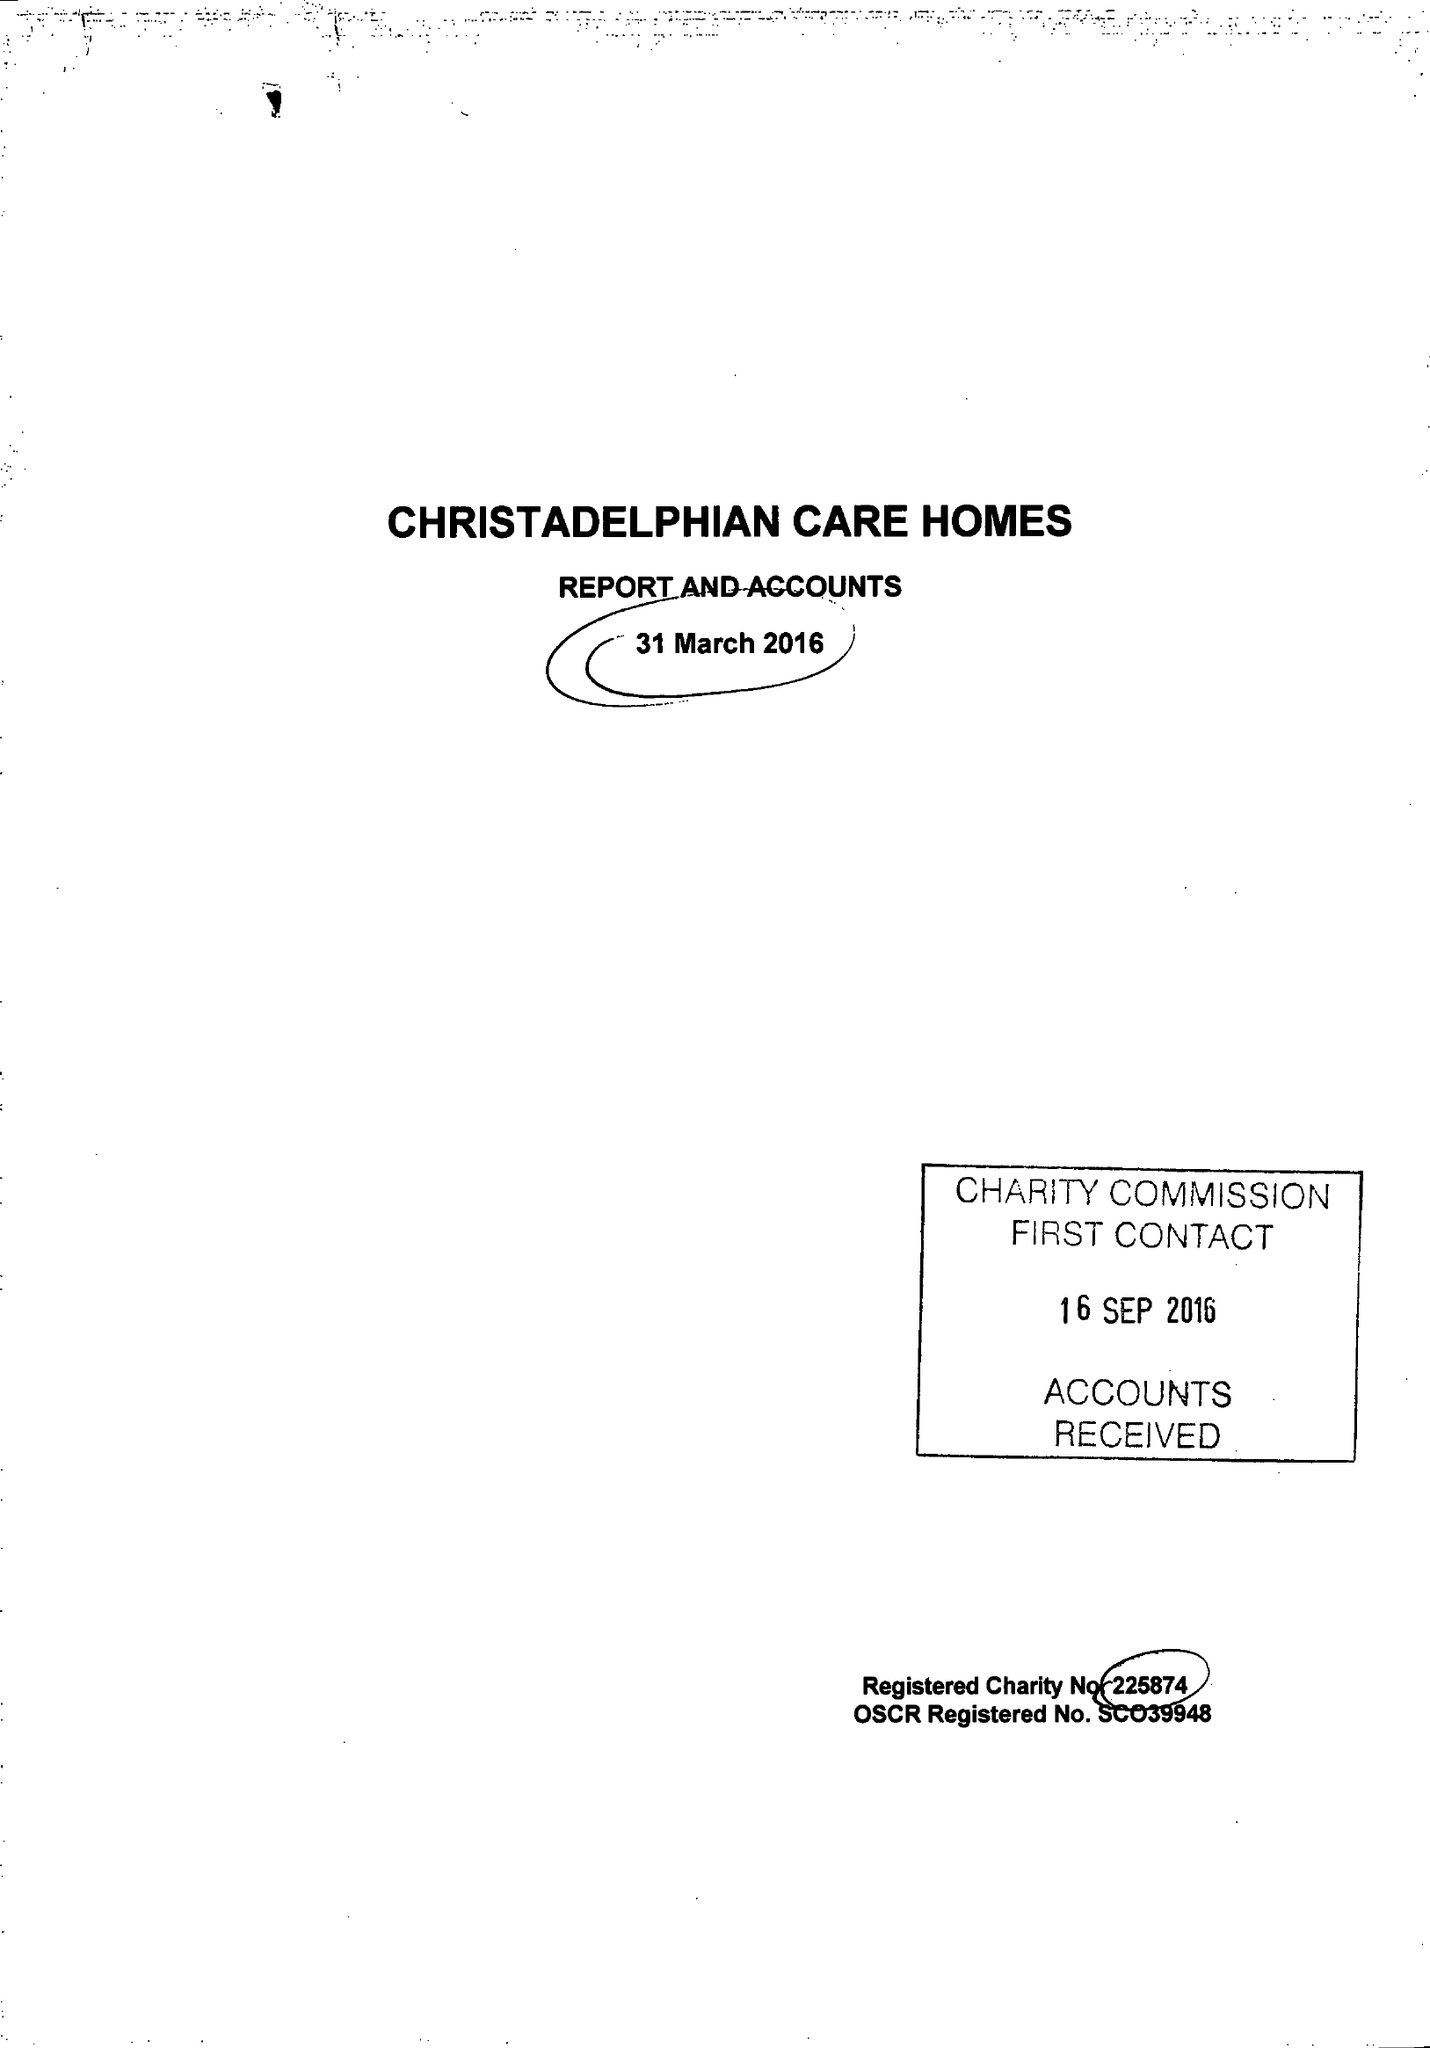What is the value for the report_date?
Answer the question using a single word or phrase. 2016-03-31 